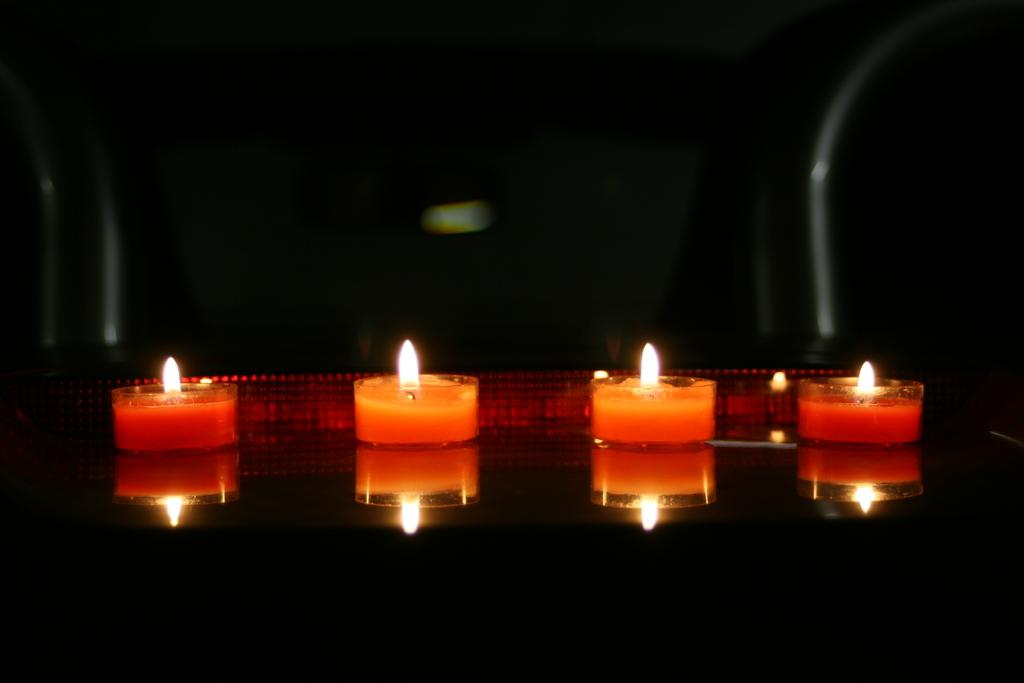What objects are present in the image? There are candles in the image. Where are the candles placed? The candles are on a glass surface. What color is the background of the image? The background of the image is black. What type of cave can be seen in the background of the image? There is no cave present in the image; the background is black. Is the queen visible in the image? There is no queen present in the image; only candles on a glass surface are visible. 